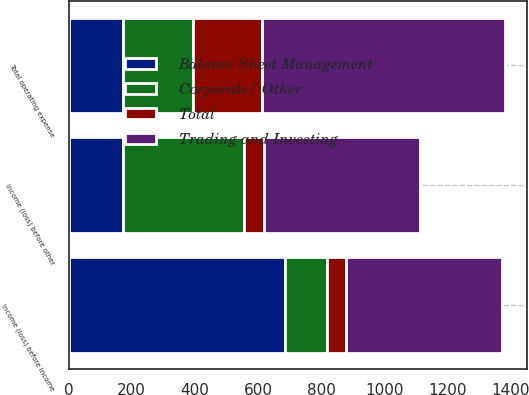<chart> <loc_0><loc_0><loc_500><loc_500><stacked_bar_chart><ecel><fcel>Total operating expense<fcel>Income (loss) before other<fcel>Income (loss) before income<nl><fcel>Trading and Investing<fcel>769<fcel>494<fcel>494<nl><fcel>Total<fcel>220<fcel>62<fcel>62<nl><fcel>Balance Sheet Management<fcel>173<fcel>173<fcel>687<nl><fcel>Corporate/ Other<fcel>220<fcel>383<fcel>131<nl></chart> 